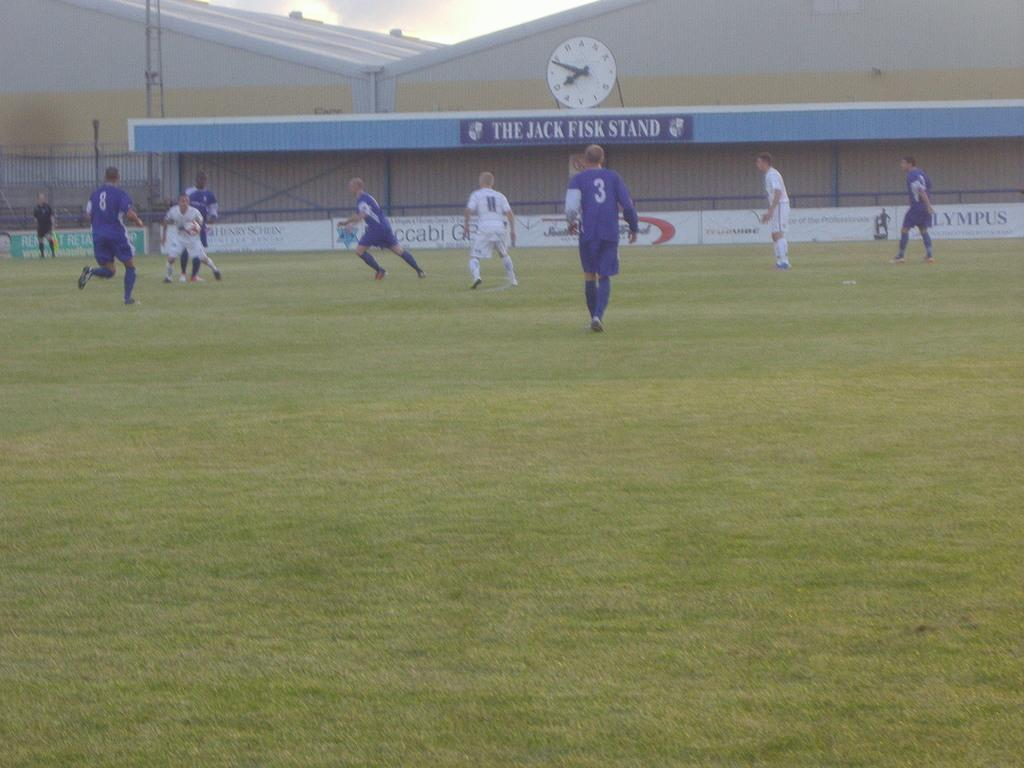Provide a one-sentence caption for the provided image. A group of people play on a field in front of the Jack Fisk stand. 